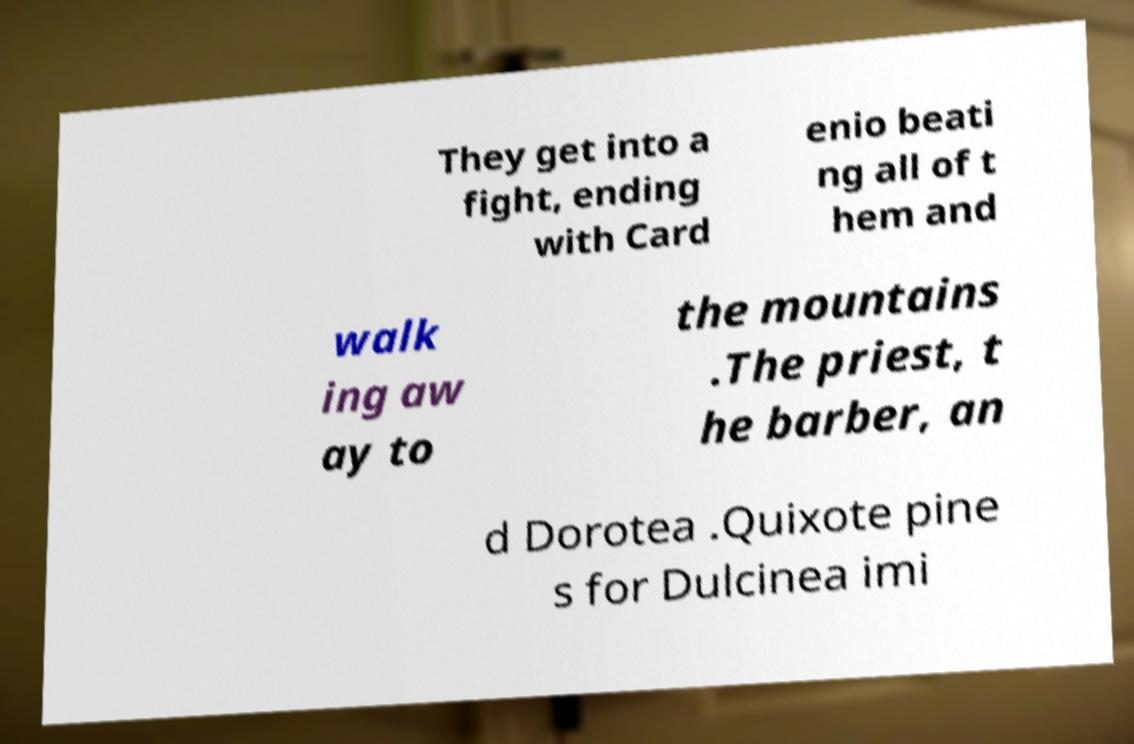Please read and relay the text visible in this image. What does it say? They get into a fight, ending with Card enio beati ng all of t hem and walk ing aw ay to the mountains .The priest, t he barber, an d Dorotea .Quixote pine s for Dulcinea imi 